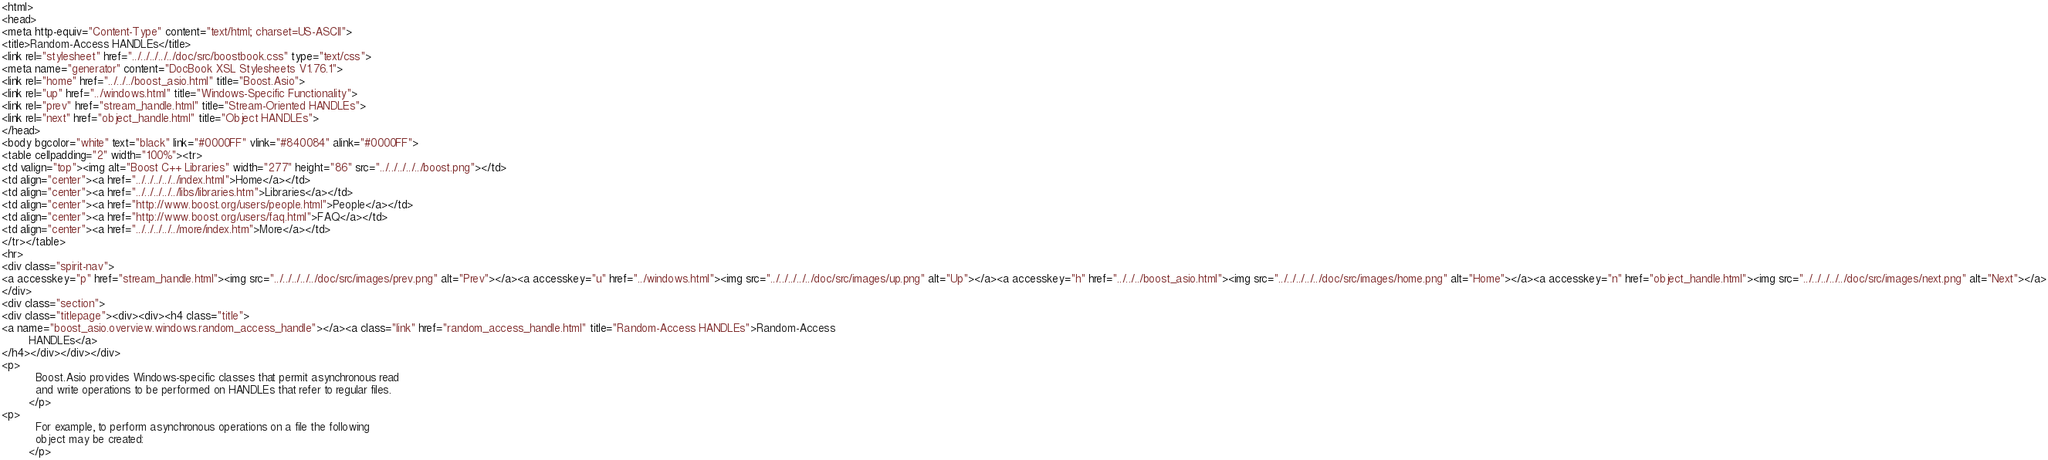Convert code to text. <code><loc_0><loc_0><loc_500><loc_500><_HTML_><html>
<head>
<meta http-equiv="Content-Type" content="text/html; charset=US-ASCII">
<title>Random-Access HANDLEs</title>
<link rel="stylesheet" href="../../../../../doc/src/boostbook.css" type="text/css">
<meta name="generator" content="DocBook XSL Stylesheets V1.76.1">
<link rel="home" href="../../../boost_asio.html" title="Boost.Asio">
<link rel="up" href="../windows.html" title="Windows-Specific Functionality">
<link rel="prev" href="stream_handle.html" title="Stream-Oriented HANDLEs">
<link rel="next" href="object_handle.html" title="Object HANDLEs">
</head>
<body bgcolor="white" text="black" link="#0000FF" vlink="#840084" alink="#0000FF">
<table cellpadding="2" width="100%"><tr>
<td valign="top"><img alt="Boost C++ Libraries" width="277" height="86" src="../../../../../boost.png"></td>
<td align="center"><a href="../../../../../index.html">Home</a></td>
<td align="center"><a href="../../../../../libs/libraries.htm">Libraries</a></td>
<td align="center"><a href="http://www.boost.org/users/people.html">People</a></td>
<td align="center"><a href="http://www.boost.org/users/faq.html">FAQ</a></td>
<td align="center"><a href="../../../../../more/index.htm">More</a></td>
</tr></table>
<hr>
<div class="spirit-nav">
<a accesskey="p" href="stream_handle.html"><img src="../../../../../doc/src/images/prev.png" alt="Prev"></a><a accesskey="u" href="../windows.html"><img src="../../../../../doc/src/images/up.png" alt="Up"></a><a accesskey="h" href="../../../boost_asio.html"><img src="../../../../../doc/src/images/home.png" alt="Home"></a><a accesskey="n" href="object_handle.html"><img src="../../../../../doc/src/images/next.png" alt="Next"></a>
</div>
<div class="section">
<div class="titlepage"><div><div><h4 class="title">
<a name="boost_asio.overview.windows.random_access_handle"></a><a class="link" href="random_access_handle.html" title="Random-Access HANDLEs">Random-Access
        HANDLEs</a>
</h4></div></div></div>
<p>
          Boost.Asio provides Windows-specific classes that permit asynchronous read
          and write operations to be performed on HANDLEs that refer to regular files.
        </p>
<p>
          For example, to perform asynchronous operations on a file the following
          object may be created:
        </p></code> 